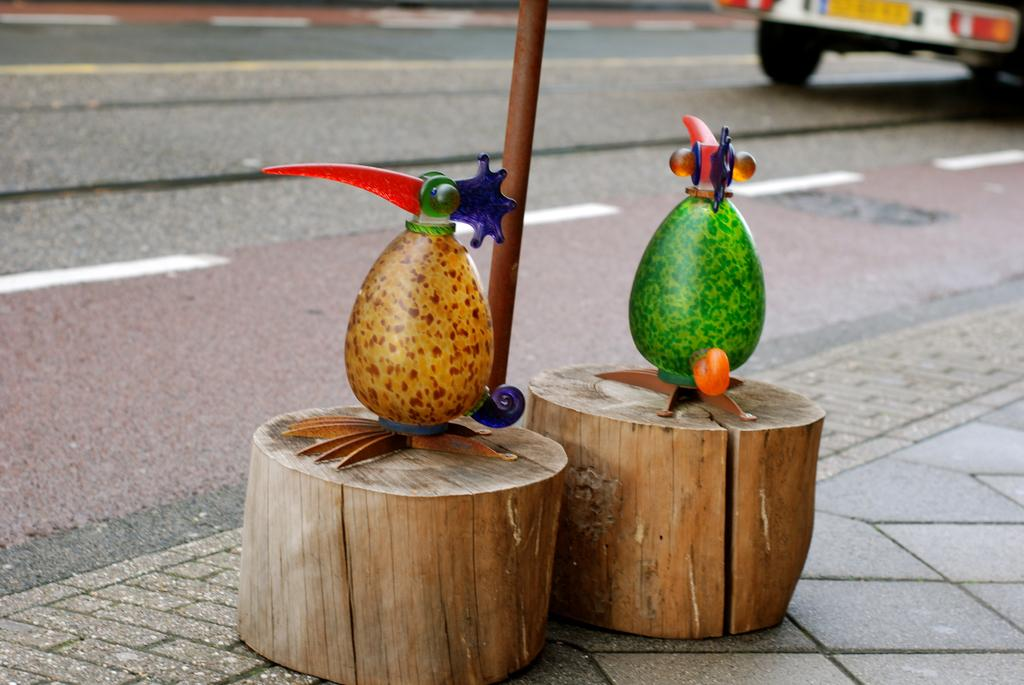What are the two objects on wooden pieces on the road? The information provided does not specify the nature of the two objects on wooden pieces on the road. Can you describe the vehicle in the background of the image? The information provided does not specify the type or characteristics of the vehicle in the background of the image. Where is the kitten playing with the scissors in the image? There is no kitten or scissors present in the image. What type of wave can be seen in the image? There is no wave present in the image. 